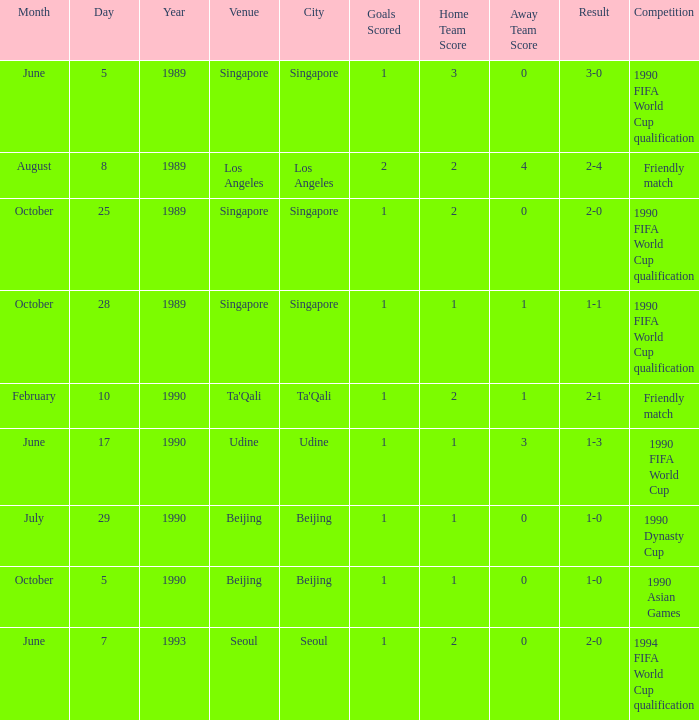What was the outcome of the game with a 3-0 result? 1 goal. 